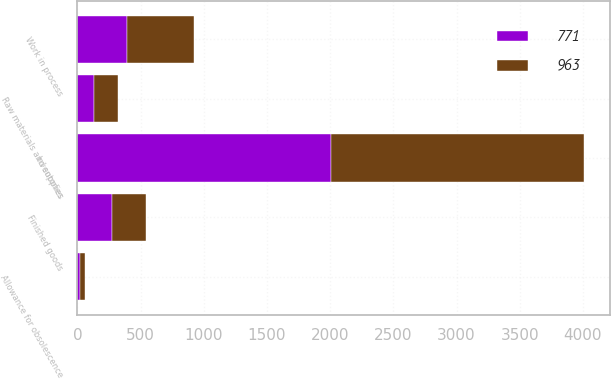<chart> <loc_0><loc_0><loc_500><loc_500><stacked_bar_chart><ecel><fcel>Inventories<fcel>Finished goods<fcel>Work in process<fcel>Raw materials and supplies<fcel>Allowance for obsolescence<nl><fcel>963<fcel>2006<fcel>273<fcel>530<fcel>195<fcel>35<nl><fcel>771<fcel>2005<fcel>271<fcel>395<fcel>129<fcel>24<nl></chart> 